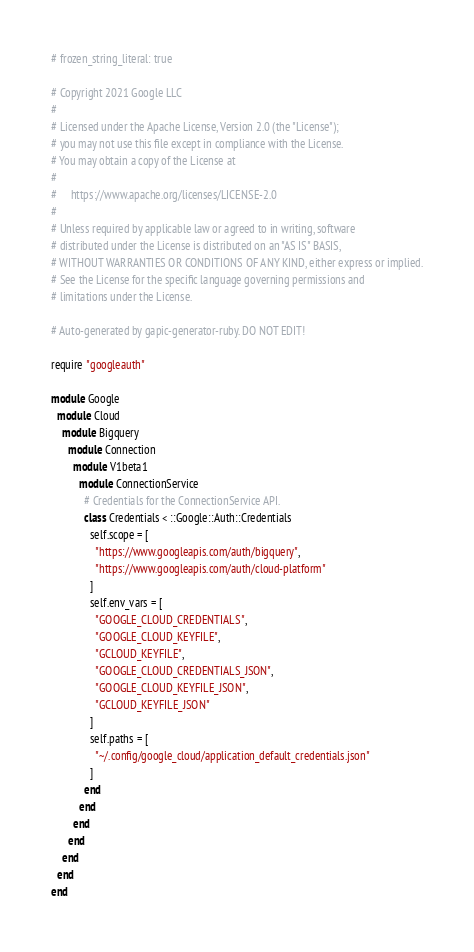Convert code to text. <code><loc_0><loc_0><loc_500><loc_500><_Ruby_># frozen_string_literal: true

# Copyright 2021 Google LLC
#
# Licensed under the Apache License, Version 2.0 (the "License");
# you may not use this file except in compliance with the License.
# You may obtain a copy of the License at
#
#     https://www.apache.org/licenses/LICENSE-2.0
#
# Unless required by applicable law or agreed to in writing, software
# distributed under the License is distributed on an "AS IS" BASIS,
# WITHOUT WARRANTIES OR CONDITIONS OF ANY KIND, either express or implied.
# See the License for the specific language governing permissions and
# limitations under the License.

# Auto-generated by gapic-generator-ruby. DO NOT EDIT!

require "googleauth"

module Google
  module Cloud
    module Bigquery
      module Connection
        module V1beta1
          module ConnectionService
            # Credentials for the ConnectionService API.
            class Credentials < ::Google::Auth::Credentials
              self.scope = [
                "https://www.googleapis.com/auth/bigquery",
                "https://www.googleapis.com/auth/cloud-platform"
              ]
              self.env_vars = [
                "GOOGLE_CLOUD_CREDENTIALS",
                "GOOGLE_CLOUD_KEYFILE",
                "GCLOUD_KEYFILE",
                "GOOGLE_CLOUD_CREDENTIALS_JSON",
                "GOOGLE_CLOUD_KEYFILE_JSON",
                "GCLOUD_KEYFILE_JSON"
              ]
              self.paths = [
                "~/.config/google_cloud/application_default_credentials.json"
              ]
            end
          end
        end
      end
    end
  end
end
</code> 